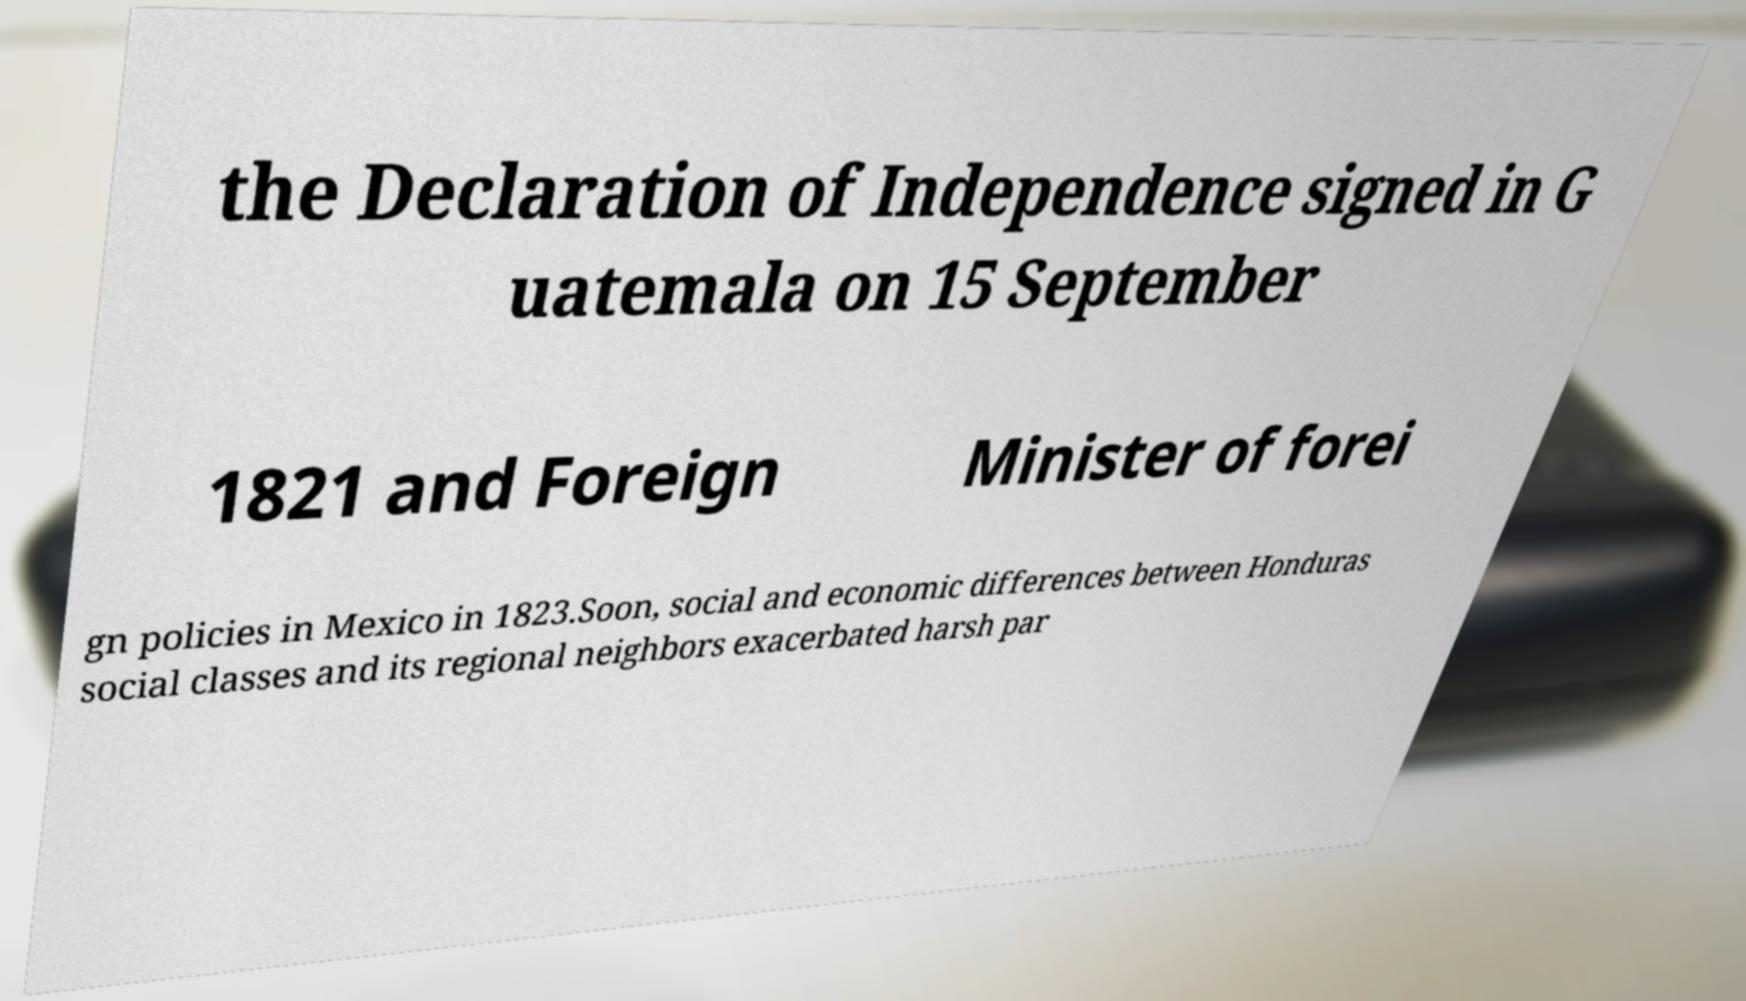What messages or text are displayed in this image? I need them in a readable, typed format. the Declaration of Independence signed in G uatemala on 15 September 1821 and Foreign Minister of forei gn policies in Mexico in 1823.Soon, social and economic differences between Honduras social classes and its regional neighbors exacerbated harsh par 